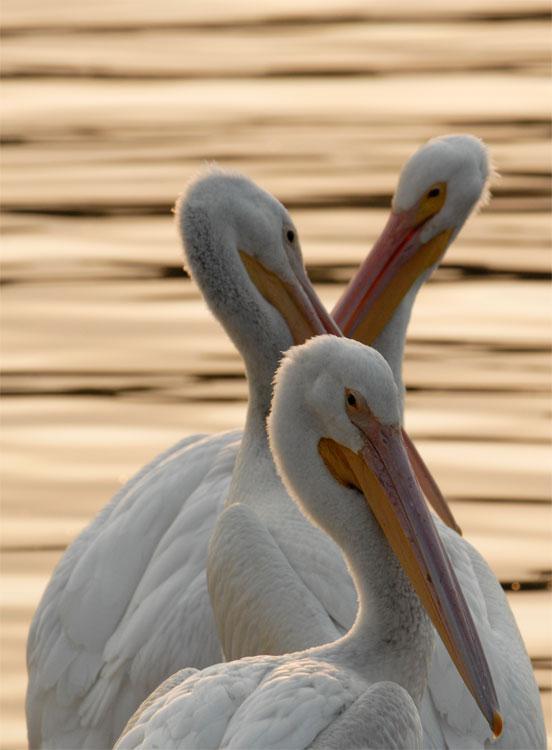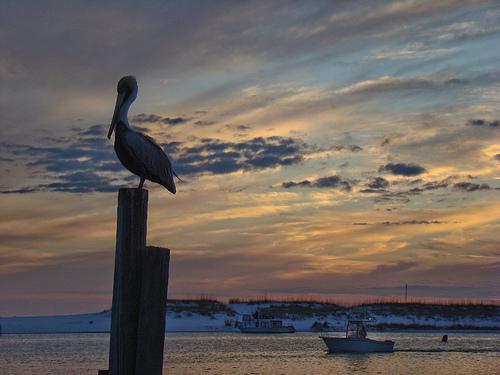The first image is the image on the left, the second image is the image on the right. Given the left and right images, does the statement "A pelican perches on a pole in the image on the left." hold true? Answer yes or no. No. The first image is the image on the left, the second image is the image on the right. Assess this claim about the two images: "An image shows a pelican perched on a tall post next to a shorter post, in front of a sky with no birds flying across it.". Correct or not? Answer yes or no. Yes. 